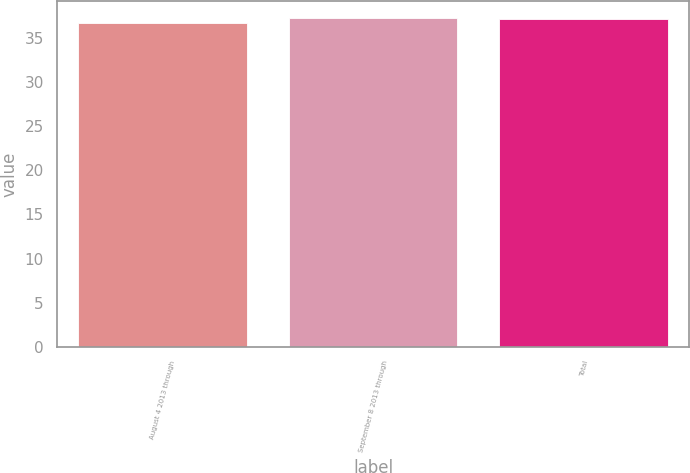<chart> <loc_0><loc_0><loc_500><loc_500><bar_chart><fcel>August 4 2013 through<fcel>September 8 2013 through<fcel>Total<nl><fcel>36.66<fcel>37.26<fcel>37.08<nl></chart> 